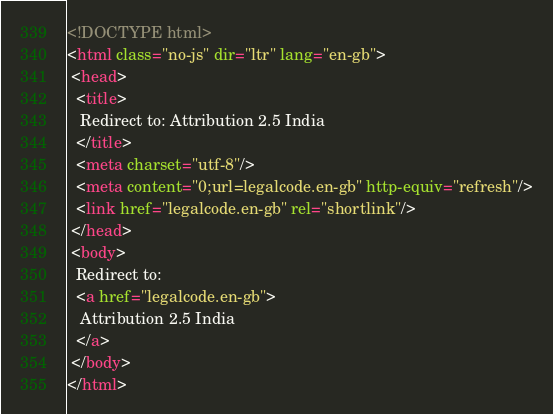<code> <loc_0><loc_0><loc_500><loc_500><_HTML_><!DOCTYPE html>
<html class="no-js" dir="ltr" lang="en-gb">
 <head>
  <title>
   Redirect to: Attribution 2.5 India
  </title>
  <meta charset="utf-8"/>
  <meta content="0;url=legalcode.en-gb" http-equiv="refresh"/>
  <link href="legalcode.en-gb" rel="shortlink"/>
 </head>
 <body>
  Redirect to:
  <a href="legalcode.en-gb">
   Attribution 2.5 India
  </a>
 </body>
</html>
</code> 